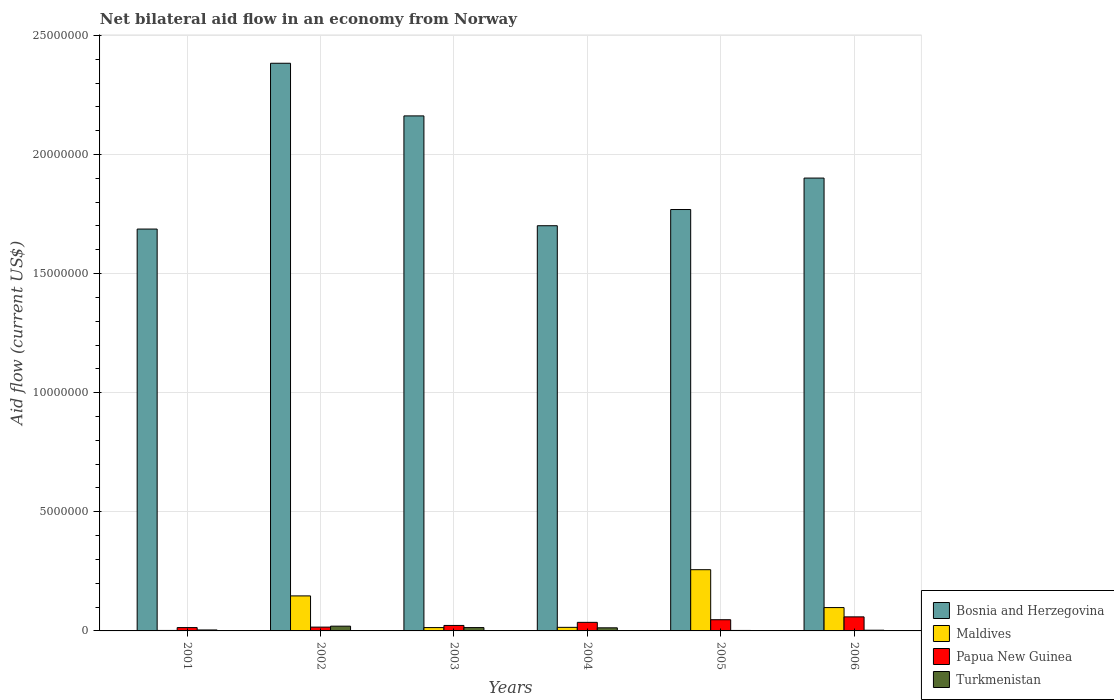How many different coloured bars are there?
Your answer should be compact. 4. How many groups of bars are there?
Give a very brief answer. 6. How many bars are there on the 4th tick from the right?
Ensure brevity in your answer.  4. What is the label of the 4th group of bars from the left?
Your answer should be compact. 2004. In how many cases, is the number of bars for a given year not equal to the number of legend labels?
Ensure brevity in your answer.  0. What is the net bilateral aid flow in Bosnia and Herzegovina in 2002?
Offer a very short reply. 2.38e+07. Across all years, what is the minimum net bilateral aid flow in Maldives?
Make the answer very short. 2.00e+04. In which year was the net bilateral aid flow in Turkmenistan maximum?
Provide a short and direct response. 2002. In which year was the net bilateral aid flow in Turkmenistan minimum?
Your answer should be very brief. 2005. What is the total net bilateral aid flow in Maldives in the graph?
Make the answer very short. 5.33e+06. What is the difference between the net bilateral aid flow in Papua New Guinea in 2003 and the net bilateral aid flow in Bosnia and Herzegovina in 2006?
Provide a succinct answer. -1.88e+07. What is the average net bilateral aid flow in Maldives per year?
Make the answer very short. 8.88e+05. In the year 2001, what is the difference between the net bilateral aid flow in Turkmenistan and net bilateral aid flow in Papua New Guinea?
Keep it short and to the point. -1.00e+05. What is the ratio of the net bilateral aid flow in Maldives in 2003 to that in 2006?
Ensure brevity in your answer.  0.14. Is the net bilateral aid flow in Maldives in 2001 less than that in 2005?
Your response must be concise. Yes. What is the difference between the highest and the second highest net bilateral aid flow in Maldives?
Provide a succinct answer. 1.10e+06. What is the difference between the highest and the lowest net bilateral aid flow in Maldives?
Give a very brief answer. 2.55e+06. In how many years, is the net bilateral aid flow in Turkmenistan greater than the average net bilateral aid flow in Turkmenistan taken over all years?
Keep it short and to the point. 3. Is the sum of the net bilateral aid flow in Papua New Guinea in 2003 and 2005 greater than the maximum net bilateral aid flow in Maldives across all years?
Provide a short and direct response. No. Is it the case that in every year, the sum of the net bilateral aid flow in Papua New Guinea and net bilateral aid flow in Turkmenistan is greater than the sum of net bilateral aid flow in Maldives and net bilateral aid flow in Bosnia and Herzegovina?
Your answer should be compact. No. What does the 1st bar from the left in 2003 represents?
Your response must be concise. Bosnia and Herzegovina. What does the 4th bar from the right in 2005 represents?
Your response must be concise. Bosnia and Herzegovina. Is it the case that in every year, the sum of the net bilateral aid flow in Turkmenistan and net bilateral aid flow in Maldives is greater than the net bilateral aid flow in Papua New Guinea?
Provide a succinct answer. No. Are all the bars in the graph horizontal?
Offer a terse response. No. How many years are there in the graph?
Your answer should be compact. 6. What is the difference between two consecutive major ticks on the Y-axis?
Your response must be concise. 5.00e+06. Are the values on the major ticks of Y-axis written in scientific E-notation?
Your response must be concise. No. Does the graph contain any zero values?
Your response must be concise. No. Does the graph contain grids?
Offer a very short reply. Yes. Where does the legend appear in the graph?
Offer a very short reply. Bottom right. What is the title of the graph?
Give a very brief answer. Net bilateral aid flow in an economy from Norway. What is the Aid flow (current US$) in Bosnia and Herzegovina in 2001?
Provide a short and direct response. 1.69e+07. What is the Aid flow (current US$) in Turkmenistan in 2001?
Provide a succinct answer. 4.00e+04. What is the Aid flow (current US$) in Bosnia and Herzegovina in 2002?
Offer a terse response. 2.38e+07. What is the Aid flow (current US$) in Maldives in 2002?
Provide a short and direct response. 1.47e+06. What is the Aid flow (current US$) of Turkmenistan in 2002?
Your response must be concise. 2.00e+05. What is the Aid flow (current US$) in Bosnia and Herzegovina in 2003?
Offer a very short reply. 2.16e+07. What is the Aid flow (current US$) in Turkmenistan in 2003?
Ensure brevity in your answer.  1.40e+05. What is the Aid flow (current US$) in Bosnia and Herzegovina in 2004?
Offer a very short reply. 1.70e+07. What is the Aid flow (current US$) of Maldives in 2004?
Your answer should be very brief. 1.50e+05. What is the Aid flow (current US$) of Bosnia and Herzegovina in 2005?
Offer a terse response. 1.77e+07. What is the Aid flow (current US$) in Maldives in 2005?
Provide a short and direct response. 2.57e+06. What is the Aid flow (current US$) in Turkmenistan in 2005?
Keep it short and to the point. 2.00e+04. What is the Aid flow (current US$) in Bosnia and Herzegovina in 2006?
Your answer should be very brief. 1.90e+07. What is the Aid flow (current US$) in Maldives in 2006?
Offer a terse response. 9.80e+05. What is the Aid flow (current US$) in Papua New Guinea in 2006?
Keep it short and to the point. 5.90e+05. Across all years, what is the maximum Aid flow (current US$) in Bosnia and Herzegovina?
Give a very brief answer. 2.38e+07. Across all years, what is the maximum Aid flow (current US$) in Maldives?
Your response must be concise. 2.57e+06. Across all years, what is the maximum Aid flow (current US$) of Papua New Guinea?
Make the answer very short. 5.90e+05. Across all years, what is the minimum Aid flow (current US$) of Bosnia and Herzegovina?
Your answer should be very brief. 1.69e+07. Across all years, what is the minimum Aid flow (current US$) in Maldives?
Your answer should be compact. 2.00e+04. What is the total Aid flow (current US$) in Bosnia and Herzegovina in the graph?
Offer a very short reply. 1.16e+08. What is the total Aid flow (current US$) of Maldives in the graph?
Offer a very short reply. 5.33e+06. What is the total Aid flow (current US$) in Papua New Guinea in the graph?
Provide a succinct answer. 1.95e+06. What is the total Aid flow (current US$) in Turkmenistan in the graph?
Your response must be concise. 5.60e+05. What is the difference between the Aid flow (current US$) of Bosnia and Herzegovina in 2001 and that in 2002?
Your answer should be compact. -6.96e+06. What is the difference between the Aid flow (current US$) of Maldives in 2001 and that in 2002?
Your answer should be very brief. -1.45e+06. What is the difference between the Aid flow (current US$) of Bosnia and Herzegovina in 2001 and that in 2003?
Provide a succinct answer. -4.75e+06. What is the difference between the Aid flow (current US$) in Bosnia and Herzegovina in 2001 and that in 2004?
Provide a short and direct response. -1.40e+05. What is the difference between the Aid flow (current US$) of Turkmenistan in 2001 and that in 2004?
Offer a very short reply. -9.00e+04. What is the difference between the Aid flow (current US$) of Bosnia and Herzegovina in 2001 and that in 2005?
Your answer should be very brief. -8.20e+05. What is the difference between the Aid flow (current US$) in Maldives in 2001 and that in 2005?
Keep it short and to the point. -2.55e+06. What is the difference between the Aid flow (current US$) in Papua New Guinea in 2001 and that in 2005?
Give a very brief answer. -3.30e+05. What is the difference between the Aid flow (current US$) of Bosnia and Herzegovina in 2001 and that in 2006?
Provide a succinct answer. -2.14e+06. What is the difference between the Aid flow (current US$) of Maldives in 2001 and that in 2006?
Ensure brevity in your answer.  -9.60e+05. What is the difference between the Aid flow (current US$) in Papua New Guinea in 2001 and that in 2006?
Provide a short and direct response. -4.50e+05. What is the difference between the Aid flow (current US$) in Bosnia and Herzegovina in 2002 and that in 2003?
Make the answer very short. 2.21e+06. What is the difference between the Aid flow (current US$) in Maldives in 2002 and that in 2003?
Provide a short and direct response. 1.33e+06. What is the difference between the Aid flow (current US$) of Turkmenistan in 2002 and that in 2003?
Keep it short and to the point. 6.00e+04. What is the difference between the Aid flow (current US$) of Bosnia and Herzegovina in 2002 and that in 2004?
Your response must be concise. 6.82e+06. What is the difference between the Aid flow (current US$) in Maldives in 2002 and that in 2004?
Give a very brief answer. 1.32e+06. What is the difference between the Aid flow (current US$) in Papua New Guinea in 2002 and that in 2004?
Ensure brevity in your answer.  -2.00e+05. What is the difference between the Aid flow (current US$) of Bosnia and Herzegovina in 2002 and that in 2005?
Your response must be concise. 6.14e+06. What is the difference between the Aid flow (current US$) in Maldives in 2002 and that in 2005?
Your answer should be very brief. -1.10e+06. What is the difference between the Aid flow (current US$) of Papua New Guinea in 2002 and that in 2005?
Keep it short and to the point. -3.10e+05. What is the difference between the Aid flow (current US$) of Turkmenistan in 2002 and that in 2005?
Your answer should be very brief. 1.80e+05. What is the difference between the Aid flow (current US$) in Bosnia and Herzegovina in 2002 and that in 2006?
Ensure brevity in your answer.  4.82e+06. What is the difference between the Aid flow (current US$) of Maldives in 2002 and that in 2006?
Offer a terse response. 4.90e+05. What is the difference between the Aid flow (current US$) of Papua New Guinea in 2002 and that in 2006?
Keep it short and to the point. -4.30e+05. What is the difference between the Aid flow (current US$) of Bosnia and Herzegovina in 2003 and that in 2004?
Offer a terse response. 4.61e+06. What is the difference between the Aid flow (current US$) of Maldives in 2003 and that in 2004?
Your response must be concise. -10000. What is the difference between the Aid flow (current US$) of Papua New Guinea in 2003 and that in 2004?
Keep it short and to the point. -1.30e+05. What is the difference between the Aid flow (current US$) of Bosnia and Herzegovina in 2003 and that in 2005?
Your answer should be compact. 3.93e+06. What is the difference between the Aid flow (current US$) in Maldives in 2003 and that in 2005?
Offer a terse response. -2.43e+06. What is the difference between the Aid flow (current US$) in Papua New Guinea in 2003 and that in 2005?
Offer a very short reply. -2.40e+05. What is the difference between the Aid flow (current US$) in Bosnia and Herzegovina in 2003 and that in 2006?
Provide a short and direct response. 2.61e+06. What is the difference between the Aid flow (current US$) in Maldives in 2003 and that in 2006?
Your response must be concise. -8.40e+05. What is the difference between the Aid flow (current US$) of Papua New Guinea in 2003 and that in 2006?
Keep it short and to the point. -3.60e+05. What is the difference between the Aid flow (current US$) in Bosnia and Herzegovina in 2004 and that in 2005?
Your answer should be very brief. -6.80e+05. What is the difference between the Aid flow (current US$) in Maldives in 2004 and that in 2005?
Your answer should be very brief. -2.42e+06. What is the difference between the Aid flow (current US$) in Papua New Guinea in 2004 and that in 2005?
Keep it short and to the point. -1.10e+05. What is the difference between the Aid flow (current US$) of Turkmenistan in 2004 and that in 2005?
Ensure brevity in your answer.  1.10e+05. What is the difference between the Aid flow (current US$) in Maldives in 2004 and that in 2006?
Your response must be concise. -8.30e+05. What is the difference between the Aid flow (current US$) in Papua New Guinea in 2004 and that in 2006?
Provide a short and direct response. -2.30e+05. What is the difference between the Aid flow (current US$) in Turkmenistan in 2004 and that in 2006?
Provide a succinct answer. 1.00e+05. What is the difference between the Aid flow (current US$) in Bosnia and Herzegovina in 2005 and that in 2006?
Keep it short and to the point. -1.32e+06. What is the difference between the Aid flow (current US$) in Maldives in 2005 and that in 2006?
Offer a terse response. 1.59e+06. What is the difference between the Aid flow (current US$) in Bosnia and Herzegovina in 2001 and the Aid flow (current US$) in Maldives in 2002?
Provide a short and direct response. 1.54e+07. What is the difference between the Aid flow (current US$) in Bosnia and Herzegovina in 2001 and the Aid flow (current US$) in Papua New Guinea in 2002?
Your answer should be compact. 1.67e+07. What is the difference between the Aid flow (current US$) in Bosnia and Herzegovina in 2001 and the Aid flow (current US$) in Turkmenistan in 2002?
Offer a terse response. 1.67e+07. What is the difference between the Aid flow (current US$) in Maldives in 2001 and the Aid flow (current US$) in Papua New Guinea in 2002?
Your answer should be compact. -1.40e+05. What is the difference between the Aid flow (current US$) of Bosnia and Herzegovina in 2001 and the Aid flow (current US$) of Maldives in 2003?
Offer a terse response. 1.67e+07. What is the difference between the Aid flow (current US$) of Bosnia and Herzegovina in 2001 and the Aid flow (current US$) of Papua New Guinea in 2003?
Offer a terse response. 1.66e+07. What is the difference between the Aid flow (current US$) of Bosnia and Herzegovina in 2001 and the Aid flow (current US$) of Turkmenistan in 2003?
Give a very brief answer. 1.67e+07. What is the difference between the Aid flow (current US$) in Papua New Guinea in 2001 and the Aid flow (current US$) in Turkmenistan in 2003?
Your response must be concise. 0. What is the difference between the Aid flow (current US$) in Bosnia and Herzegovina in 2001 and the Aid flow (current US$) in Maldives in 2004?
Your response must be concise. 1.67e+07. What is the difference between the Aid flow (current US$) in Bosnia and Herzegovina in 2001 and the Aid flow (current US$) in Papua New Guinea in 2004?
Offer a terse response. 1.65e+07. What is the difference between the Aid flow (current US$) of Bosnia and Herzegovina in 2001 and the Aid flow (current US$) of Turkmenistan in 2004?
Give a very brief answer. 1.67e+07. What is the difference between the Aid flow (current US$) in Bosnia and Herzegovina in 2001 and the Aid flow (current US$) in Maldives in 2005?
Your answer should be very brief. 1.43e+07. What is the difference between the Aid flow (current US$) of Bosnia and Herzegovina in 2001 and the Aid flow (current US$) of Papua New Guinea in 2005?
Your answer should be very brief. 1.64e+07. What is the difference between the Aid flow (current US$) in Bosnia and Herzegovina in 2001 and the Aid flow (current US$) in Turkmenistan in 2005?
Provide a short and direct response. 1.68e+07. What is the difference between the Aid flow (current US$) of Maldives in 2001 and the Aid flow (current US$) of Papua New Guinea in 2005?
Your answer should be compact. -4.50e+05. What is the difference between the Aid flow (current US$) in Bosnia and Herzegovina in 2001 and the Aid flow (current US$) in Maldives in 2006?
Offer a very short reply. 1.59e+07. What is the difference between the Aid flow (current US$) in Bosnia and Herzegovina in 2001 and the Aid flow (current US$) in Papua New Guinea in 2006?
Offer a terse response. 1.63e+07. What is the difference between the Aid flow (current US$) in Bosnia and Herzegovina in 2001 and the Aid flow (current US$) in Turkmenistan in 2006?
Your response must be concise. 1.68e+07. What is the difference between the Aid flow (current US$) of Maldives in 2001 and the Aid flow (current US$) of Papua New Guinea in 2006?
Provide a short and direct response. -5.70e+05. What is the difference between the Aid flow (current US$) in Maldives in 2001 and the Aid flow (current US$) in Turkmenistan in 2006?
Your answer should be very brief. -10000. What is the difference between the Aid flow (current US$) of Papua New Guinea in 2001 and the Aid flow (current US$) of Turkmenistan in 2006?
Your response must be concise. 1.10e+05. What is the difference between the Aid flow (current US$) in Bosnia and Herzegovina in 2002 and the Aid flow (current US$) in Maldives in 2003?
Give a very brief answer. 2.37e+07. What is the difference between the Aid flow (current US$) of Bosnia and Herzegovina in 2002 and the Aid flow (current US$) of Papua New Guinea in 2003?
Make the answer very short. 2.36e+07. What is the difference between the Aid flow (current US$) of Bosnia and Herzegovina in 2002 and the Aid flow (current US$) of Turkmenistan in 2003?
Provide a short and direct response. 2.37e+07. What is the difference between the Aid flow (current US$) of Maldives in 2002 and the Aid flow (current US$) of Papua New Guinea in 2003?
Make the answer very short. 1.24e+06. What is the difference between the Aid flow (current US$) of Maldives in 2002 and the Aid flow (current US$) of Turkmenistan in 2003?
Your answer should be very brief. 1.33e+06. What is the difference between the Aid flow (current US$) in Bosnia and Herzegovina in 2002 and the Aid flow (current US$) in Maldives in 2004?
Your answer should be very brief. 2.37e+07. What is the difference between the Aid flow (current US$) in Bosnia and Herzegovina in 2002 and the Aid flow (current US$) in Papua New Guinea in 2004?
Offer a terse response. 2.35e+07. What is the difference between the Aid flow (current US$) in Bosnia and Herzegovina in 2002 and the Aid flow (current US$) in Turkmenistan in 2004?
Your answer should be compact. 2.37e+07. What is the difference between the Aid flow (current US$) in Maldives in 2002 and the Aid flow (current US$) in Papua New Guinea in 2004?
Offer a terse response. 1.11e+06. What is the difference between the Aid flow (current US$) in Maldives in 2002 and the Aid flow (current US$) in Turkmenistan in 2004?
Your response must be concise. 1.34e+06. What is the difference between the Aid flow (current US$) in Papua New Guinea in 2002 and the Aid flow (current US$) in Turkmenistan in 2004?
Offer a terse response. 3.00e+04. What is the difference between the Aid flow (current US$) of Bosnia and Herzegovina in 2002 and the Aid flow (current US$) of Maldives in 2005?
Give a very brief answer. 2.13e+07. What is the difference between the Aid flow (current US$) in Bosnia and Herzegovina in 2002 and the Aid flow (current US$) in Papua New Guinea in 2005?
Ensure brevity in your answer.  2.34e+07. What is the difference between the Aid flow (current US$) of Bosnia and Herzegovina in 2002 and the Aid flow (current US$) of Turkmenistan in 2005?
Make the answer very short. 2.38e+07. What is the difference between the Aid flow (current US$) of Maldives in 2002 and the Aid flow (current US$) of Turkmenistan in 2005?
Your response must be concise. 1.45e+06. What is the difference between the Aid flow (current US$) of Papua New Guinea in 2002 and the Aid flow (current US$) of Turkmenistan in 2005?
Give a very brief answer. 1.40e+05. What is the difference between the Aid flow (current US$) of Bosnia and Herzegovina in 2002 and the Aid flow (current US$) of Maldives in 2006?
Your answer should be very brief. 2.28e+07. What is the difference between the Aid flow (current US$) in Bosnia and Herzegovina in 2002 and the Aid flow (current US$) in Papua New Guinea in 2006?
Your answer should be compact. 2.32e+07. What is the difference between the Aid flow (current US$) in Bosnia and Herzegovina in 2002 and the Aid flow (current US$) in Turkmenistan in 2006?
Ensure brevity in your answer.  2.38e+07. What is the difference between the Aid flow (current US$) of Maldives in 2002 and the Aid flow (current US$) of Papua New Guinea in 2006?
Keep it short and to the point. 8.80e+05. What is the difference between the Aid flow (current US$) of Maldives in 2002 and the Aid flow (current US$) of Turkmenistan in 2006?
Your response must be concise. 1.44e+06. What is the difference between the Aid flow (current US$) of Papua New Guinea in 2002 and the Aid flow (current US$) of Turkmenistan in 2006?
Provide a succinct answer. 1.30e+05. What is the difference between the Aid flow (current US$) of Bosnia and Herzegovina in 2003 and the Aid flow (current US$) of Maldives in 2004?
Provide a short and direct response. 2.15e+07. What is the difference between the Aid flow (current US$) of Bosnia and Herzegovina in 2003 and the Aid flow (current US$) of Papua New Guinea in 2004?
Offer a very short reply. 2.13e+07. What is the difference between the Aid flow (current US$) in Bosnia and Herzegovina in 2003 and the Aid flow (current US$) in Turkmenistan in 2004?
Keep it short and to the point. 2.15e+07. What is the difference between the Aid flow (current US$) of Maldives in 2003 and the Aid flow (current US$) of Turkmenistan in 2004?
Keep it short and to the point. 10000. What is the difference between the Aid flow (current US$) in Papua New Guinea in 2003 and the Aid flow (current US$) in Turkmenistan in 2004?
Your answer should be compact. 1.00e+05. What is the difference between the Aid flow (current US$) of Bosnia and Herzegovina in 2003 and the Aid flow (current US$) of Maldives in 2005?
Provide a short and direct response. 1.90e+07. What is the difference between the Aid flow (current US$) of Bosnia and Herzegovina in 2003 and the Aid flow (current US$) of Papua New Guinea in 2005?
Your answer should be compact. 2.12e+07. What is the difference between the Aid flow (current US$) in Bosnia and Herzegovina in 2003 and the Aid flow (current US$) in Turkmenistan in 2005?
Ensure brevity in your answer.  2.16e+07. What is the difference between the Aid flow (current US$) of Maldives in 2003 and the Aid flow (current US$) of Papua New Guinea in 2005?
Make the answer very short. -3.30e+05. What is the difference between the Aid flow (current US$) in Papua New Guinea in 2003 and the Aid flow (current US$) in Turkmenistan in 2005?
Offer a very short reply. 2.10e+05. What is the difference between the Aid flow (current US$) of Bosnia and Herzegovina in 2003 and the Aid flow (current US$) of Maldives in 2006?
Offer a terse response. 2.06e+07. What is the difference between the Aid flow (current US$) in Bosnia and Herzegovina in 2003 and the Aid flow (current US$) in Papua New Guinea in 2006?
Your answer should be compact. 2.10e+07. What is the difference between the Aid flow (current US$) in Bosnia and Herzegovina in 2003 and the Aid flow (current US$) in Turkmenistan in 2006?
Make the answer very short. 2.16e+07. What is the difference between the Aid flow (current US$) of Maldives in 2003 and the Aid flow (current US$) of Papua New Guinea in 2006?
Your response must be concise. -4.50e+05. What is the difference between the Aid flow (current US$) in Maldives in 2003 and the Aid flow (current US$) in Turkmenistan in 2006?
Offer a terse response. 1.10e+05. What is the difference between the Aid flow (current US$) in Bosnia and Herzegovina in 2004 and the Aid flow (current US$) in Maldives in 2005?
Ensure brevity in your answer.  1.44e+07. What is the difference between the Aid flow (current US$) in Bosnia and Herzegovina in 2004 and the Aid flow (current US$) in Papua New Guinea in 2005?
Offer a very short reply. 1.65e+07. What is the difference between the Aid flow (current US$) in Bosnia and Herzegovina in 2004 and the Aid flow (current US$) in Turkmenistan in 2005?
Ensure brevity in your answer.  1.70e+07. What is the difference between the Aid flow (current US$) of Maldives in 2004 and the Aid flow (current US$) of Papua New Guinea in 2005?
Your answer should be very brief. -3.20e+05. What is the difference between the Aid flow (current US$) in Papua New Guinea in 2004 and the Aid flow (current US$) in Turkmenistan in 2005?
Offer a very short reply. 3.40e+05. What is the difference between the Aid flow (current US$) in Bosnia and Herzegovina in 2004 and the Aid flow (current US$) in Maldives in 2006?
Give a very brief answer. 1.60e+07. What is the difference between the Aid flow (current US$) of Bosnia and Herzegovina in 2004 and the Aid flow (current US$) of Papua New Guinea in 2006?
Provide a short and direct response. 1.64e+07. What is the difference between the Aid flow (current US$) in Bosnia and Herzegovina in 2004 and the Aid flow (current US$) in Turkmenistan in 2006?
Make the answer very short. 1.70e+07. What is the difference between the Aid flow (current US$) in Maldives in 2004 and the Aid flow (current US$) in Papua New Guinea in 2006?
Keep it short and to the point. -4.40e+05. What is the difference between the Aid flow (current US$) of Maldives in 2004 and the Aid flow (current US$) of Turkmenistan in 2006?
Ensure brevity in your answer.  1.20e+05. What is the difference between the Aid flow (current US$) of Bosnia and Herzegovina in 2005 and the Aid flow (current US$) of Maldives in 2006?
Provide a succinct answer. 1.67e+07. What is the difference between the Aid flow (current US$) in Bosnia and Herzegovina in 2005 and the Aid flow (current US$) in Papua New Guinea in 2006?
Keep it short and to the point. 1.71e+07. What is the difference between the Aid flow (current US$) of Bosnia and Herzegovina in 2005 and the Aid flow (current US$) of Turkmenistan in 2006?
Provide a succinct answer. 1.77e+07. What is the difference between the Aid flow (current US$) in Maldives in 2005 and the Aid flow (current US$) in Papua New Guinea in 2006?
Offer a very short reply. 1.98e+06. What is the difference between the Aid flow (current US$) of Maldives in 2005 and the Aid flow (current US$) of Turkmenistan in 2006?
Give a very brief answer. 2.54e+06. What is the average Aid flow (current US$) in Bosnia and Herzegovina per year?
Ensure brevity in your answer.  1.93e+07. What is the average Aid flow (current US$) in Maldives per year?
Ensure brevity in your answer.  8.88e+05. What is the average Aid flow (current US$) in Papua New Guinea per year?
Provide a succinct answer. 3.25e+05. What is the average Aid flow (current US$) in Turkmenistan per year?
Keep it short and to the point. 9.33e+04. In the year 2001, what is the difference between the Aid flow (current US$) of Bosnia and Herzegovina and Aid flow (current US$) of Maldives?
Provide a succinct answer. 1.68e+07. In the year 2001, what is the difference between the Aid flow (current US$) in Bosnia and Herzegovina and Aid flow (current US$) in Papua New Guinea?
Your response must be concise. 1.67e+07. In the year 2001, what is the difference between the Aid flow (current US$) in Bosnia and Herzegovina and Aid flow (current US$) in Turkmenistan?
Provide a succinct answer. 1.68e+07. In the year 2001, what is the difference between the Aid flow (current US$) in Maldives and Aid flow (current US$) in Turkmenistan?
Give a very brief answer. -2.00e+04. In the year 2001, what is the difference between the Aid flow (current US$) in Papua New Guinea and Aid flow (current US$) in Turkmenistan?
Keep it short and to the point. 1.00e+05. In the year 2002, what is the difference between the Aid flow (current US$) of Bosnia and Herzegovina and Aid flow (current US$) of Maldives?
Your answer should be compact. 2.24e+07. In the year 2002, what is the difference between the Aid flow (current US$) of Bosnia and Herzegovina and Aid flow (current US$) of Papua New Guinea?
Your answer should be very brief. 2.37e+07. In the year 2002, what is the difference between the Aid flow (current US$) in Bosnia and Herzegovina and Aid flow (current US$) in Turkmenistan?
Make the answer very short. 2.36e+07. In the year 2002, what is the difference between the Aid flow (current US$) in Maldives and Aid flow (current US$) in Papua New Guinea?
Ensure brevity in your answer.  1.31e+06. In the year 2002, what is the difference between the Aid flow (current US$) of Maldives and Aid flow (current US$) of Turkmenistan?
Provide a short and direct response. 1.27e+06. In the year 2003, what is the difference between the Aid flow (current US$) in Bosnia and Herzegovina and Aid flow (current US$) in Maldives?
Provide a succinct answer. 2.15e+07. In the year 2003, what is the difference between the Aid flow (current US$) in Bosnia and Herzegovina and Aid flow (current US$) in Papua New Guinea?
Offer a terse response. 2.14e+07. In the year 2003, what is the difference between the Aid flow (current US$) in Bosnia and Herzegovina and Aid flow (current US$) in Turkmenistan?
Make the answer very short. 2.15e+07. In the year 2003, what is the difference between the Aid flow (current US$) of Maldives and Aid flow (current US$) of Papua New Guinea?
Ensure brevity in your answer.  -9.00e+04. In the year 2003, what is the difference between the Aid flow (current US$) in Maldives and Aid flow (current US$) in Turkmenistan?
Your answer should be very brief. 0. In the year 2003, what is the difference between the Aid flow (current US$) of Papua New Guinea and Aid flow (current US$) of Turkmenistan?
Keep it short and to the point. 9.00e+04. In the year 2004, what is the difference between the Aid flow (current US$) in Bosnia and Herzegovina and Aid flow (current US$) in Maldives?
Your response must be concise. 1.69e+07. In the year 2004, what is the difference between the Aid flow (current US$) of Bosnia and Herzegovina and Aid flow (current US$) of Papua New Guinea?
Keep it short and to the point. 1.66e+07. In the year 2004, what is the difference between the Aid flow (current US$) of Bosnia and Herzegovina and Aid flow (current US$) of Turkmenistan?
Give a very brief answer. 1.69e+07. In the year 2004, what is the difference between the Aid flow (current US$) in Maldives and Aid flow (current US$) in Turkmenistan?
Keep it short and to the point. 2.00e+04. In the year 2004, what is the difference between the Aid flow (current US$) in Papua New Guinea and Aid flow (current US$) in Turkmenistan?
Give a very brief answer. 2.30e+05. In the year 2005, what is the difference between the Aid flow (current US$) in Bosnia and Herzegovina and Aid flow (current US$) in Maldives?
Provide a succinct answer. 1.51e+07. In the year 2005, what is the difference between the Aid flow (current US$) of Bosnia and Herzegovina and Aid flow (current US$) of Papua New Guinea?
Provide a short and direct response. 1.72e+07. In the year 2005, what is the difference between the Aid flow (current US$) in Bosnia and Herzegovina and Aid flow (current US$) in Turkmenistan?
Your answer should be compact. 1.77e+07. In the year 2005, what is the difference between the Aid flow (current US$) of Maldives and Aid flow (current US$) of Papua New Guinea?
Your answer should be very brief. 2.10e+06. In the year 2005, what is the difference between the Aid flow (current US$) in Maldives and Aid flow (current US$) in Turkmenistan?
Give a very brief answer. 2.55e+06. In the year 2005, what is the difference between the Aid flow (current US$) of Papua New Guinea and Aid flow (current US$) of Turkmenistan?
Your answer should be compact. 4.50e+05. In the year 2006, what is the difference between the Aid flow (current US$) of Bosnia and Herzegovina and Aid flow (current US$) of Maldives?
Provide a succinct answer. 1.80e+07. In the year 2006, what is the difference between the Aid flow (current US$) in Bosnia and Herzegovina and Aid flow (current US$) in Papua New Guinea?
Make the answer very short. 1.84e+07. In the year 2006, what is the difference between the Aid flow (current US$) in Bosnia and Herzegovina and Aid flow (current US$) in Turkmenistan?
Ensure brevity in your answer.  1.90e+07. In the year 2006, what is the difference between the Aid flow (current US$) of Maldives and Aid flow (current US$) of Turkmenistan?
Keep it short and to the point. 9.50e+05. In the year 2006, what is the difference between the Aid flow (current US$) in Papua New Guinea and Aid flow (current US$) in Turkmenistan?
Make the answer very short. 5.60e+05. What is the ratio of the Aid flow (current US$) of Bosnia and Herzegovina in 2001 to that in 2002?
Provide a succinct answer. 0.71. What is the ratio of the Aid flow (current US$) in Maldives in 2001 to that in 2002?
Keep it short and to the point. 0.01. What is the ratio of the Aid flow (current US$) of Papua New Guinea in 2001 to that in 2002?
Give a very brief answer. 0.88. What is the ratio of the Aid flow (current US$) of Bosnia and Herzegovina in 2001 to that in 2003?
Offer a terse response. 0.78. What is the ratio of the Aid flow (current US$) in Maldives in 2001 to that in 2003?
Provide a succinct answer. 0.14. What is the ratio of the Aid flow (current US$) in Papua New Guinea in 2001 to that in 2003?
Give a very brief answer. 0.61. What is the ratio of the Aid flow (current US$) of Turkmenistan in 2001 to that in 2003?
Your response must be concise. 0.29. What is the ratio of the Aid flow (current US$) in Maldives in 2001 to that in 2004?
Your answer should be very brief. 0.13. What is the ratio of the Aid flow (current US$) in Papua New Guinea in 2001 to that in 2004?
Your answer should be very brief. 0.39. What is the ratio of the Aid flow (current US$) of Turkmenistan in 2001 to that in 2004?
Provide a succinct answer. 0.31. What is the ratio of the Aid flow (current US$) of Bosnia and Herzegovina in 2001 to that in 2005?
Keep it short and to the point. 0.95. What is the ratio of the Aid flow (current US$) in Maldives in 2001 to that in 2005?
Offer a very short reply. 0.01. What is the ratio of the Aid flow (current US$) in Papua New Guinea in 2001 to that in 2005?
Keep it short and to the point. 0.3. What is the ratio of the Aid flow (current US$) in Bosnia and Herzegovina in 2001 to that in 2006?
Your answer should be very brief. 0.89. What is the ratio of the Aid flow (current US$) of Maldives in 2001 to that in 2006?
Your response must be concise. 0.02. What is the ratio of the Aid flow (current US$) of Papua New Guinea in 2001 to that in 2006?
Offer a very short reply. 0.24. What is the ratio of the Aid flow (current US$) of Bosnia and Herzegovina in 2002 to that in 2003?
Offer a terse response. 1.1. What is the ratio of the Aid flow (current US$) of Papua New Guinea in 2002 to that in 2003?
Offer a very short reply. 0.7. What is the ratio of the Aid flow (current US$) of Turkmenistan in 2002 to that in 2003?
Keep it short and to the point. 1.43. What is the ratio of the Aid flow (current US$) in Bosnia and Herzegovina in 2002 to that in 2004?
Keep it short and to the point. 1.4. What is the ratio of the Aid flow (current US$) of Papua New Guinea in 2002 to that in 2004?
Make the answer very short. 0.44. What is the ratio of the Aid flow (current US$) in Turkmenistan in 2002 to that in 2004?
Your answer should be compact. 1.54. What is the ratio of the Aid flow (current US$) in Bosnia and Herzegovina in 2002 to that in 2005?
Your answer should be very brief. 1.35. What is the ratio of the Aid flow (current US$) in Maldives in 2002 to that in 2005?
Provide a succinct answer. 0.57. What is the ratio of the Aid flow (current US$) in Papua New Guinea in 2002 to that in 2005?
Offer a terse response. 0.34. What is the ratio of the Aid flow (current US$) in Bosnia and Herzegovina in 2002 to that in 2006?
Your answer should be very brief. 1.25. What is the ratio of the Aid flow (current US$) in Maldives in 2002 to that in 2006?
Offer a very short reply. 1.5. What is the ratio of the Aid flow (current US$) of Papua New Guinea in 2002 to that in 2006?
Offer a terse response. 0.27. What is the ratio of the Aid flow (current US$) of Bosnia and Herzegovina in 2003 to that in 2004?
Make the answer very short. 1.27. What is the ratio of the Aid flow (current US$) in Papua New Guinea in 2003 to that in 2004?
Provide a succinct answer. 0.64. What is the ratio of the Aid flow (current US$) in Turkmenistan in 2003 to that in 2004?
Give a very brief answer. 1.08. What is the ratio of the Aid flow (current US$) of Bosnia and Herzegovina in 2003 to that in 2005?
Offer a very short reply. 1.22. What is the ratio of the Aid flow (current US$) in Maldives in 2003 to that in 2005?
Your answer should be compact. 0.05. What is the ratio of the Aid flow (current US$) of Papua New Guinea in 2003 to that in 2005?
Your answer should be very brief. 0.49. What is the ratio of the Aid flow (current US$) of Bosnia and Herzegovina in 2003 to that in 2006?
Your response must be concise. 1.14. What is the ratio of the Aid flow (current US$) of Maldives in 2003 to that in 2006?
Offer a terse response. 0.14. What is the ratio of the Aid flow (current US$) in Papua New Guinea in 2003 to that in 2006?
Your answer should be very brief. 0.39. What is the ratio of the Aid flow (current US$) in Turkmenistan in 2003 to that in 2006?
Your answer should be compact. 4.67. What is the ratio of the Aid flow (current US$) in Bosnia and Herzegovina in 2004 to that in 2005?
Provide a short and direct response. 0.96. What is the ratio of the Aid flow (current US$) in Maldives in 2004 to that in 2005?
Your answer should be very brief. 0.06. What is the ratio of the Aid flow (current US$) in Papua New Guinea in 2004 to that in 2005?
Your answer should be very brief. 0.77. What is the ratio of the Aid flow (current US$) of Bosnia and Herzegovina in 2004 to that in 2006?
Make the answer very short. 0.89. What is the ratio of the Aid flow (current US$) in Maldives in 2004 to that in 2006?
Your response must be concise. 0.15. What is the ratio of the Aid flow (current US$) of Papua New Guinea in 2004 to that in 2006?
Provide a short and direct response. 0.61. What is the ratio of the Aid flow (current US$) of Turkmenistan in 2004 to that in 2006?
Give a very brief answer. 4.33. What is the ratio of the Aid flow (current US$) of Bosnia and Herzegovina in 2005 to that in 2006?
Provide a short and direct response. 0.93. What is the ratio of the Aid flow (current US$) of Maldives in 2005 to that in 2006?
Provide a succinct answer. 2.62. What is the ratio of the Aid flow (current US$) in Papua New Guinea in 2005 to that in 2006?
Your response must be concise. 0.8. What is the ratio of the Aid flow (current US$) in Turkmenistan in 2005 to that in 2006?
Offer a very short reply. 0.67. What is the difference between the highest and the second highest Aid flow (current US$) of Bosnia and Herzegovina?
Offer a very short reply. 2.21e+06. What is the difference between the highest and the second highest Aid flow (current US$) of Maldives?
Your answer should be compact. 1.10e+06. What is the difference between the highest and the second highest Aid flow (current US$) of Papua New Guinea?
Make the answer very short. 1.20e+05. What is the difference between the highest and the second highest Aid flow (current US$) in Turkmenistan?
Offer a terse response. 6.00e+04. What is the difference between the highest and the lowest Aid flow (current US$) of Bosnia and Herzegovina?
Provide a succinct answer. 6.96e+06. What is the difference between the highest and the lowest Aid flow (current US$) in Maldives?
Ensure brevity in your answer.  2.55e+06. What is the difference between the highest and the lowest Aid flow (current US$) of Papua New Guinea?
Give a very brief answer. 4.50e+05. What is the difference between the highest and the lowest Aid flow (current US$) of Turkmenistan?
Your answer should be very brief. 1.80e+05. 